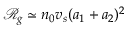Convert formula to latex. <formula><loc_0><loc_0><loc_500><loc_500>\ m a t h s c r { R } _ { g } \simeq n _ { 0 } v _ { s } ( a _ { 1 } + a _ { 2 } ) ^ { 2 }</formula> 